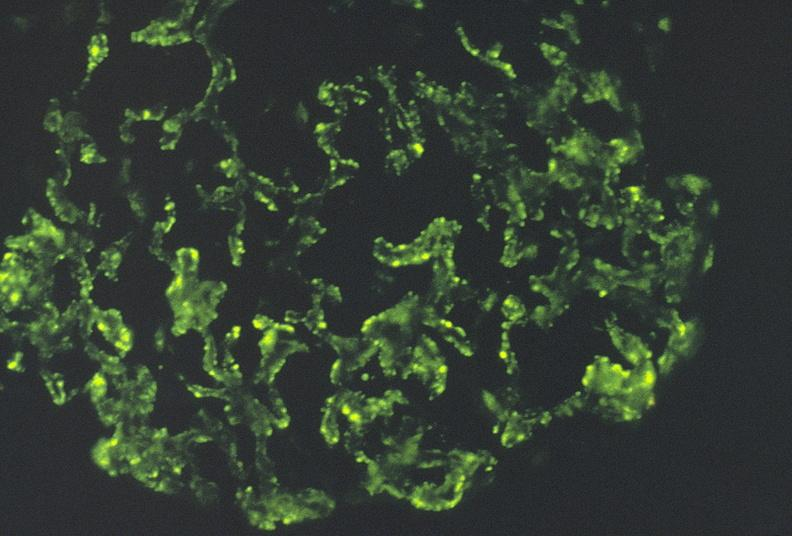what does this image show?
Answer the question using a single word or phrase. Sle iv 